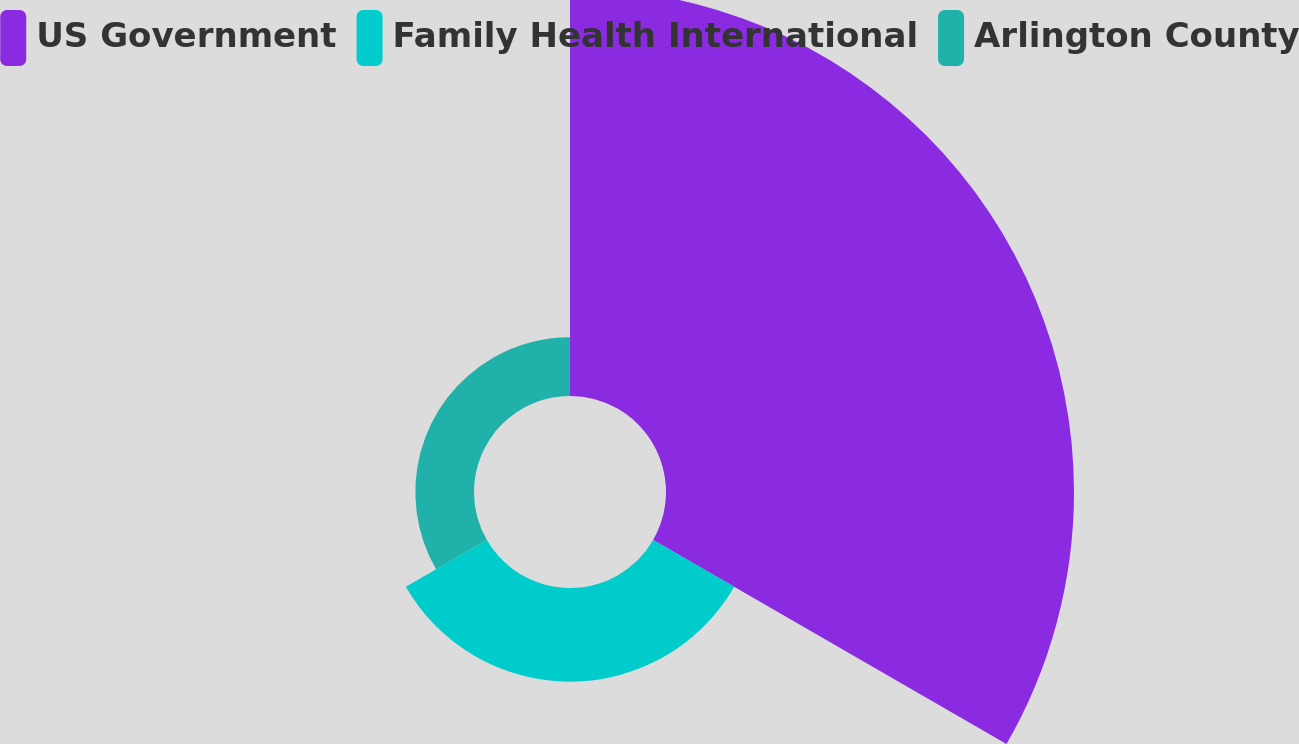Convert chart. <chart><loc_0><loc_0><loc_500><loc_500><pie_chart><fcel>US Government<fcel>Family Health International<fcel>Arlington County<nl><fcel>72.82%<fcel>16.71%<fcel>10.47%<nl></chart> 